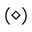Convert formula to latex. <formula><loc_0><loc_0><loc_500><loc_500>( \diamond )</formula> 